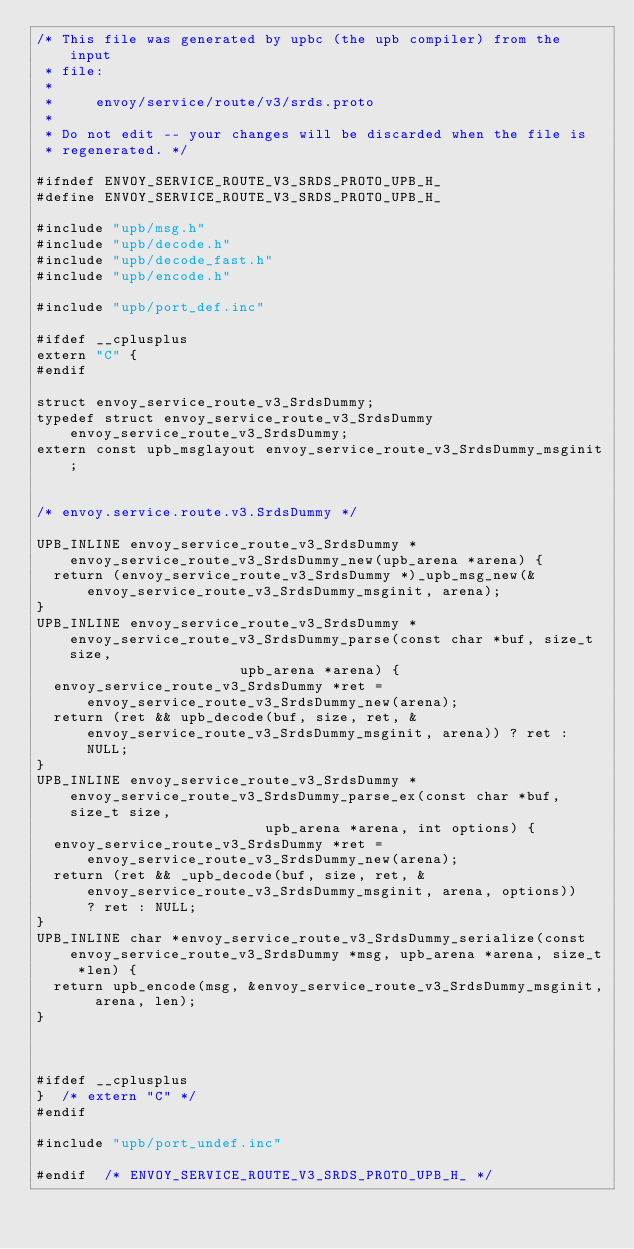Convert code to text. <code><loc_0><loc_0><loc_500><loc_500><_C_>/* This file was generated by upbc (the upb compiler) from the input
 * file:
 *
 *     envoy/service/route/v3/srds.proto
 *
 * Do not edit -- your changes will be discarded when the file is
 * regenerated. */

#ifndef ENVOY_SERVICE_ROUTE_V3_SRDS_PROTO_UPB_H_
#define ENVOY_SERVICE_ROUTE_V3_SRDS_PROTO_UPB_H_

#include "upb/msg.h"
#include "upb/decode.h"
#include "upb/decode_fast.h"
#include "upb/encode.h"

#include "upb/port_def.inc"

#ifdef __cplusplus
extern "C" {
#endif

struct envoy_service_route_v3_SrdsDummy;
typedef struct envoy_service_route_v3_SrdsDummy envoy_service_route_v3_SrdsDummy;
extern const upb_msglayout envoy_service_route_v3_SrdsDummy_msginit;


/* envoy.service.route.v3.SrdsDummy */

UPB_INLINE envoy_service_route_v3_SrdsDummy *envoy_service_route_v3_SrdsDummy_new(upb_arena *arena) {
  return (envoy_service_route_v3_SrdsDummy *)_upb_msg_new(&envoy_service_route_v3_SrdsDummy_msginit, arena);
}
UPB_INLINE envoy_service_route_v3_SrdsDummy *envoy_service_route_v3_SrdsDummy_parse(const char *buf, size_t size,
                        upb_arena *arena) {
  envoy_service_route_v3_SrdsDummy *ret = envoy_service_route_v3_SrdsDummy_new(arena);
  return (ret && upb_decode(buf, size, ret, &envoy_service_route_v3_SrdsDummy_msginit, arena)) ? ret : NULL;
}
UPB_INLINE envoy_service_route_v3_SrdsDummy *envoy_service_route_v3_SrdsDummy_parse_ex(const char *buf, size_t size,
                           upb_arena *arena, int options) {
  envoy_service_route_v3_SrdsDummy *ret = envoy_service_route_v3_SrdsDummy_new(arena);
  return (ret && _upb_decode(buf, size, ret, &envoy_service_route_v3_SrdsDummy_msginit, arena, options))
      ? ret : NULL;
}
UPB_INLINE char *envoy_service_route_v3_SrdsDummy_serialize(const envoy_service_route_v3_SrdsDummy *msg, upb_arena *arena, size_t *len) {
  return upb_encode(msg, &envoy_service_route_v3_SrdsDummy_msginit, arena, len);
}



#ifdef __cplusplus
}  /* extern "C" */
#endif

#include "upb/port_undef.inc"

#endif  /* ENVOY_SERVICE_ROUTE_V3_SRDS_PROTO_UPB_H_ */
</code> 